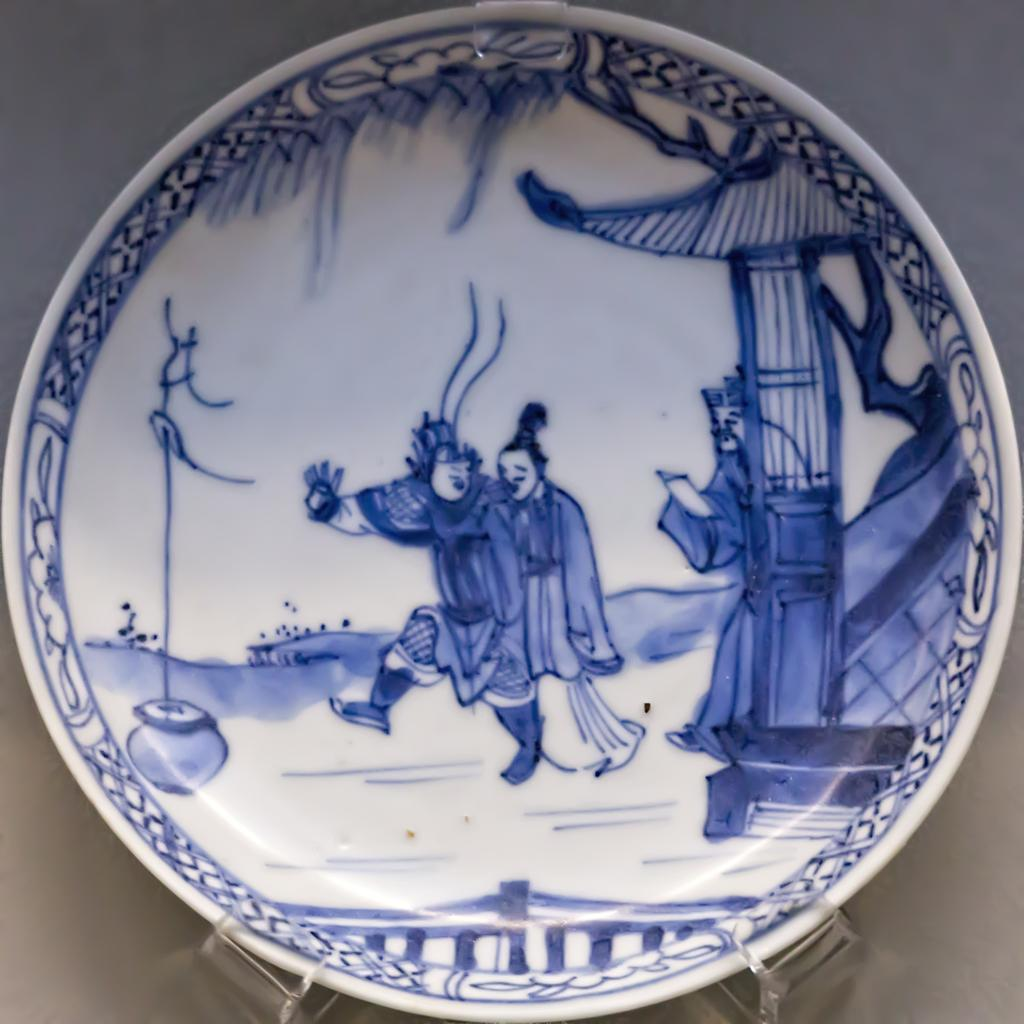What is on the plate in the image? There is a plate with blue color paint in the image. How many people are present in the image? There are three people with paint on them in the image. What structure can be seen in the image? There is a pillar in the image. What natural element is present in the image? There is a branch of a tree in the image. What is visible in the background of the image? The sky is visible in the image. Can you see any fairies flying around the tree branch in the image? There are no fairies present in the image; it only features a plate with blue color paint, three people with paint on them, a pillar, a tree branch, and the sky. What type of flock is visible in the image? There is no flock present in the image. 